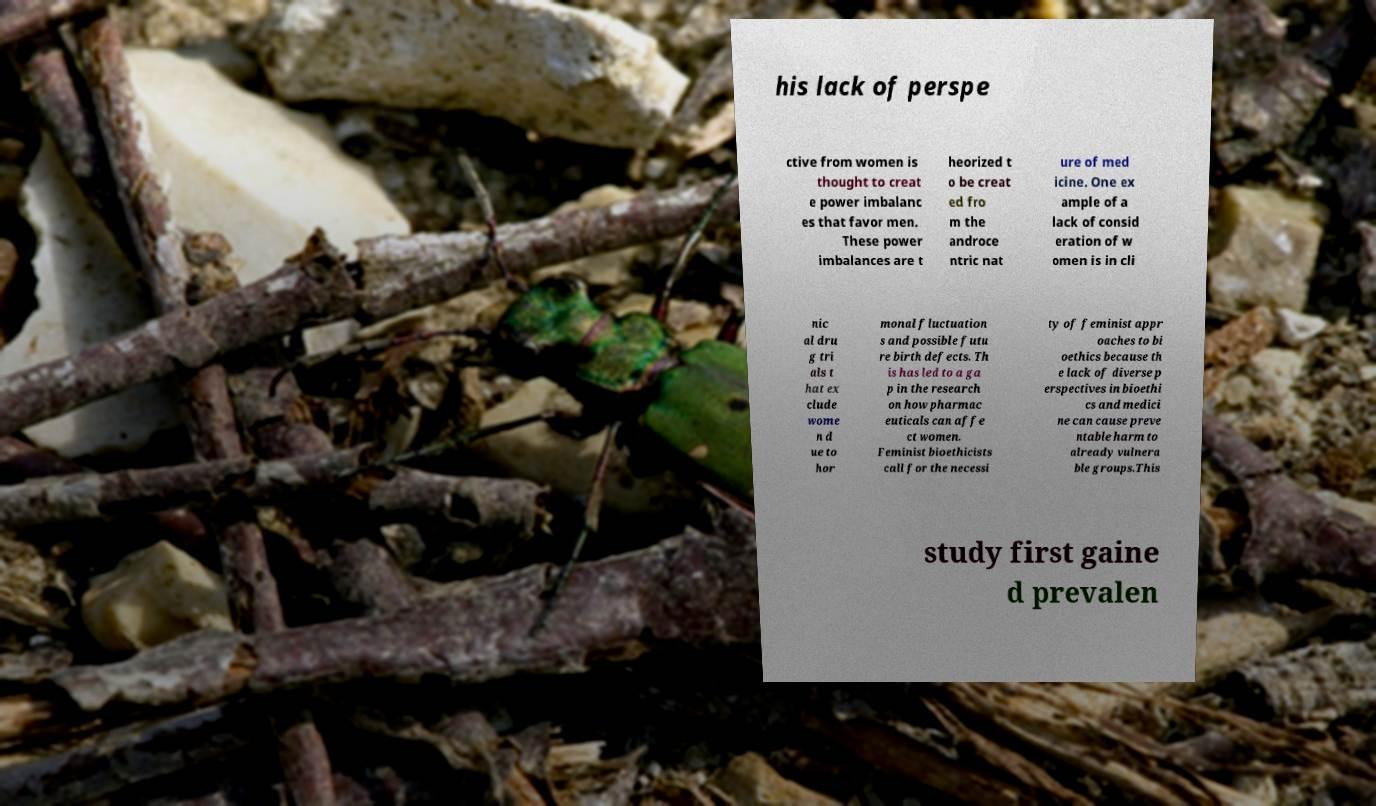Please read and relay the text visible in this image. What does it say? his lack of perspe ctive from women is thought to creat e power imbalanc es that favor men. These power imbalances are t heorized t o be creat ed fro m the androce ntric nat ure of med icine. One ex ample of a lack of consid eration of w omen is in cli nic al dru g tri als t hat ex clude wome n d ue to hor monal fluctuation s and possible futu re birth defects. Th is has led to a ga p in the research on how pharmac euticals can affe ct women. Feminist bioethicists call for the necessi ty of feminist appr oaches to bi oethics because th e lack of diverse p erspectives in bioethi cs and medici ne can cause preve ntable harm to already vulnera ble groups.This study first gaine d prevalen 